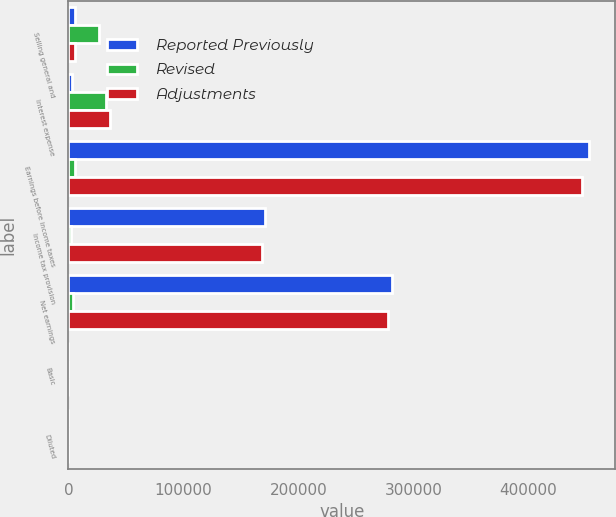<chart> <loc_0><loc_0><loc_500><loc_500><stacked_bar_chart><ecel><fcel>Selling general and<fcel>Interest expense<fcel>Earnings before income taxes<fcel>Income tax provision<fcel>Net earnings<fcel>Basic<fcel>Diluted<nl><fcel>Reported Previously<fcel>6044<fcel>3460<fcel>452496<fcel>170828<fcel>281668<fcel>1.27<fcel>1.26<nl><fcel>Revised<fcel>26490<fcel>32534<fcel>6044<fcel>2220<fcel>3824<fcel>0.02<fcel>0.02<nl><fcel>Adjustments<fcel>6044<fcel>35994<fcel>446452<fcel>168608<fcel>277844<fcel>1.25<fcel>1.24<nl></chart> 